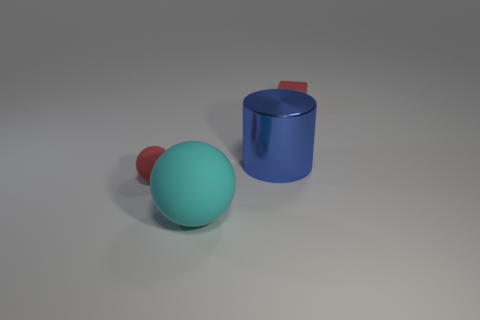Subtract all yellow cubes. Subtract all brown cylinders. How many cubes are left? 1 Add 4 tiny blue cylinders. How many objects exist? 8 Subtract all cylinders. How many objects are left? 3 Subtract all tiny blue matte things. Subtract all metal cylinders. How many objects are left? 3 Add 3 rubber spheres. How many rubber spheres are left? 5 Add 4 rubber cylinders. How many rubber cylinders exist? 4 Subtract 0 yellow cubes. How many objects are left? 4 